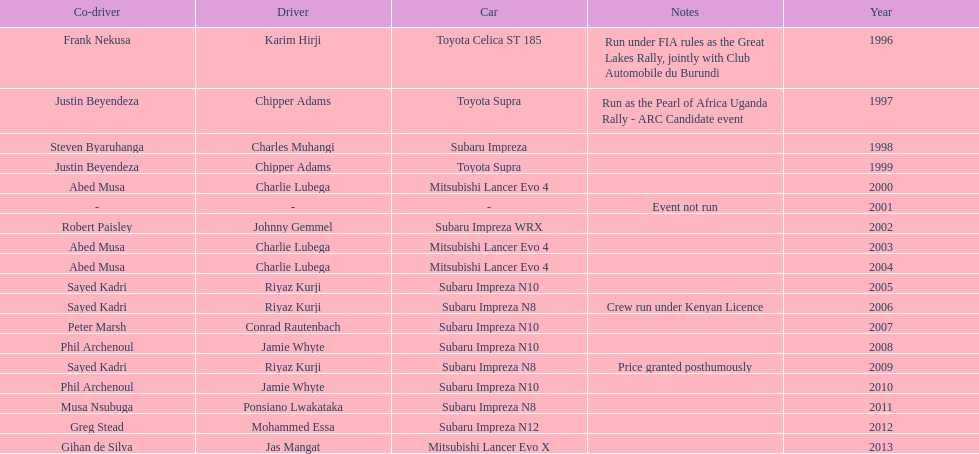How many times was a mitsubishi lancer the winning car before the year 2004? 2. 